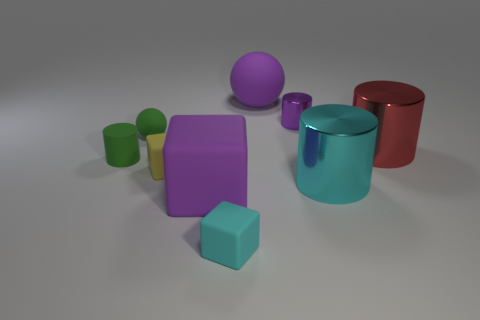Subtract all purple spheres. Subtract all red cubes. How many spheres are left? 1 Add 1 tiny purple things. How many objects exist? 10 Subtract all spheres. How many objects are left? 7 Add 1 tiny cyan things. How many tiny cyan things are left? 2 Add 8 purple shiny objects. How many purple shiny objects exist? 9 Subtract 0 blue cubes. How many objects are left? 9 Subtract all purple shiny things. Subtract all cyan cubes. How many objects are left? 7 